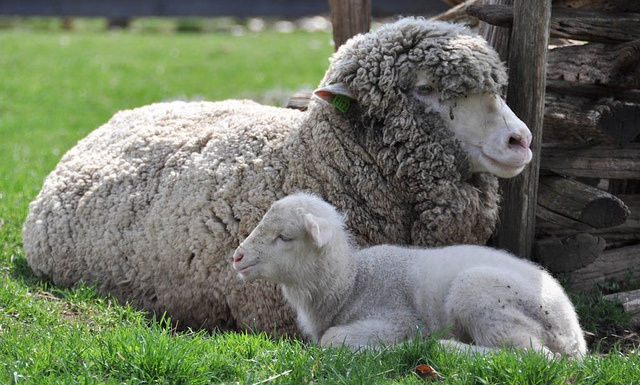Describe the objects in this image and their specific colors. I can see sheep in black, gray, darkgray, and lightgray tones and sheep in black, darkgray, gray, and lightgray tones in this image. 